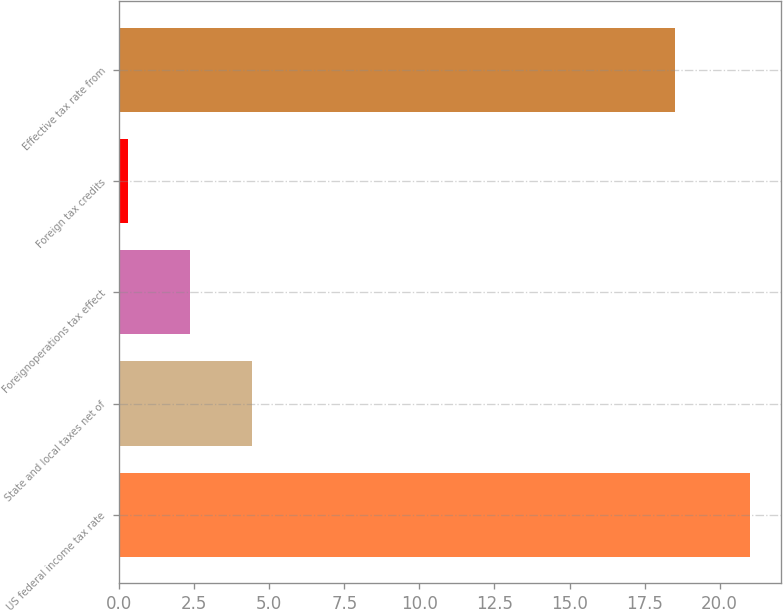Convert chart to OTSL. <chart><loc_0><loc_0><loc_500><loc_500><bar_chart><fcel>US federal income tax rate<fcel>State and local taxes net of<fcel>Foreignoperations tax effect<fcel>Foreign tax credits<fcel>Effective tax rate from<nl><fcel>21<fcel>4.44<fcel>2.37<fcel>0.3<fcel>18.5<nl></chart> 